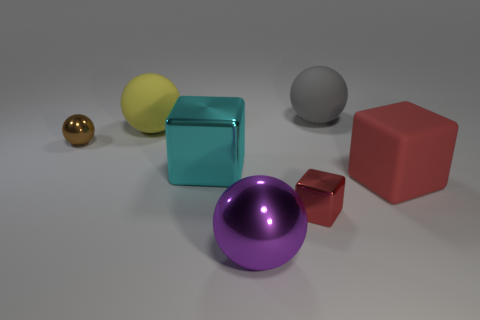There is a big cyan shiny cube; what number of big balls are to the left of it?
Offer a terse response. 1. What is the material of the gray ball?
Offer a terse response. Rubber. Do the big matte cube and the small block have the same color?
Give a very brief answer. Yes. Are there fewer large blocks that are left of the tiny red shiny object than tiny blocks?
Provide a short and direct response. No. The large sphere that is in front of the yellow sphere is what color?
Offer a terse response. Purple. There is a gray rubber thing; what shape is it?
Give a very brief answer. Sphere. There is a small red object right of the large sphere in front of the red matte thing; are there any big purple objects that are left of it?
Offer a very short reply. Yes. There is a small shiny block to the left of the rubber sphere on the right side of the rubber object that is on the left side of the red shiny object; what is its color?
Provide a succinct answer. Red. What material is the purple object that is the same shape as the yellow matte thing?
Ensure brevity in your answer.  Metal. There is a block that is on the left side of the thing that is in front of the small red cube; how big is it?
Provide a short and direct response. Large. 